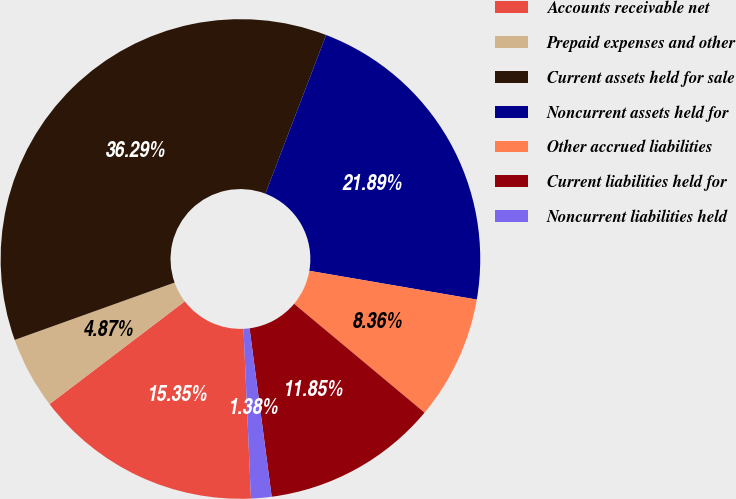<chart> <loc_0><loc_0><loc_500><loc_500><pie_chart><fcel>Accounts receivable net<fcel>Prepaid expenses and other<fcel>Current assets held for sale<fcel>Noncurrent assets held for<fcel>Other accrued liabilities<fcel>Current liabilities held for<fcel>Noncurrent liabilities held<nl><fcel>15.35%<fcel>4.87%<fcel>36.29%<fcel>21.89%<fcel>8.36%<fcel>11.85%<fcel>1.38%<nl></chart> 